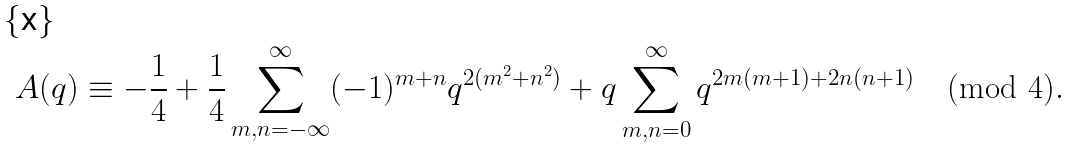<formula> <loc_0><loc_0><loc_500><loc_500>A ( q ) \equiv - \frac { 1 } { 4 } + \frac { 1 } { 4 } \sum _ { m , n = - \infty } ^ { \infty } ( - 1 ) ^ { m + n } q ^ { 2 ( m ^ { 2 } + n ^ { 2 } ) } + q \sum _ { m , n = 0 } ^ { \infty } q ^ { 2 m ( m + 1 ) + 2 n ( n + 1 ) } \pmod { 4 } .</formula> 